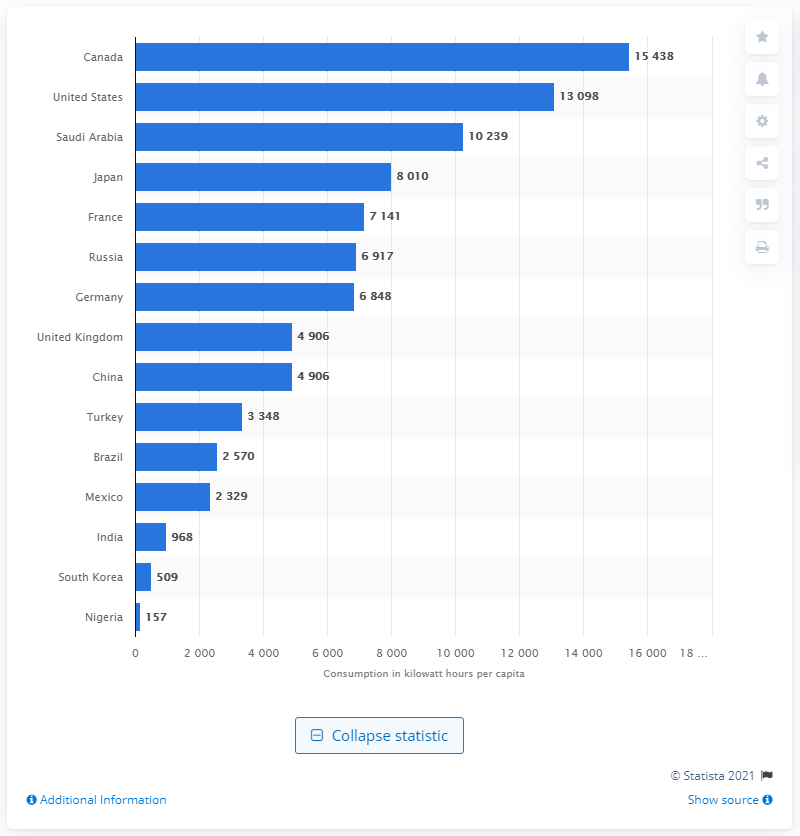Point out several critical features in this image. Canada has the greatest per capita consumption of electricity among all countries in the world. 